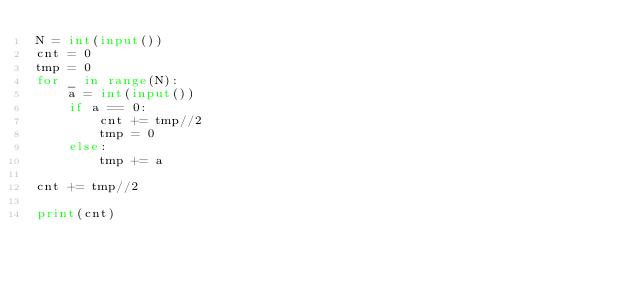<code> <loc_0><loc_0><loc_500><loc_500><_Python_>N = int(input())
cnt = 0
tmp = 0
for _ in range(N):
    a = int(input())
    if a == 0:
        cnt += tmp//2
        tmp = 0
    else:
        tmp += a

cnt += tmp//2

print(cnt)
</code> 